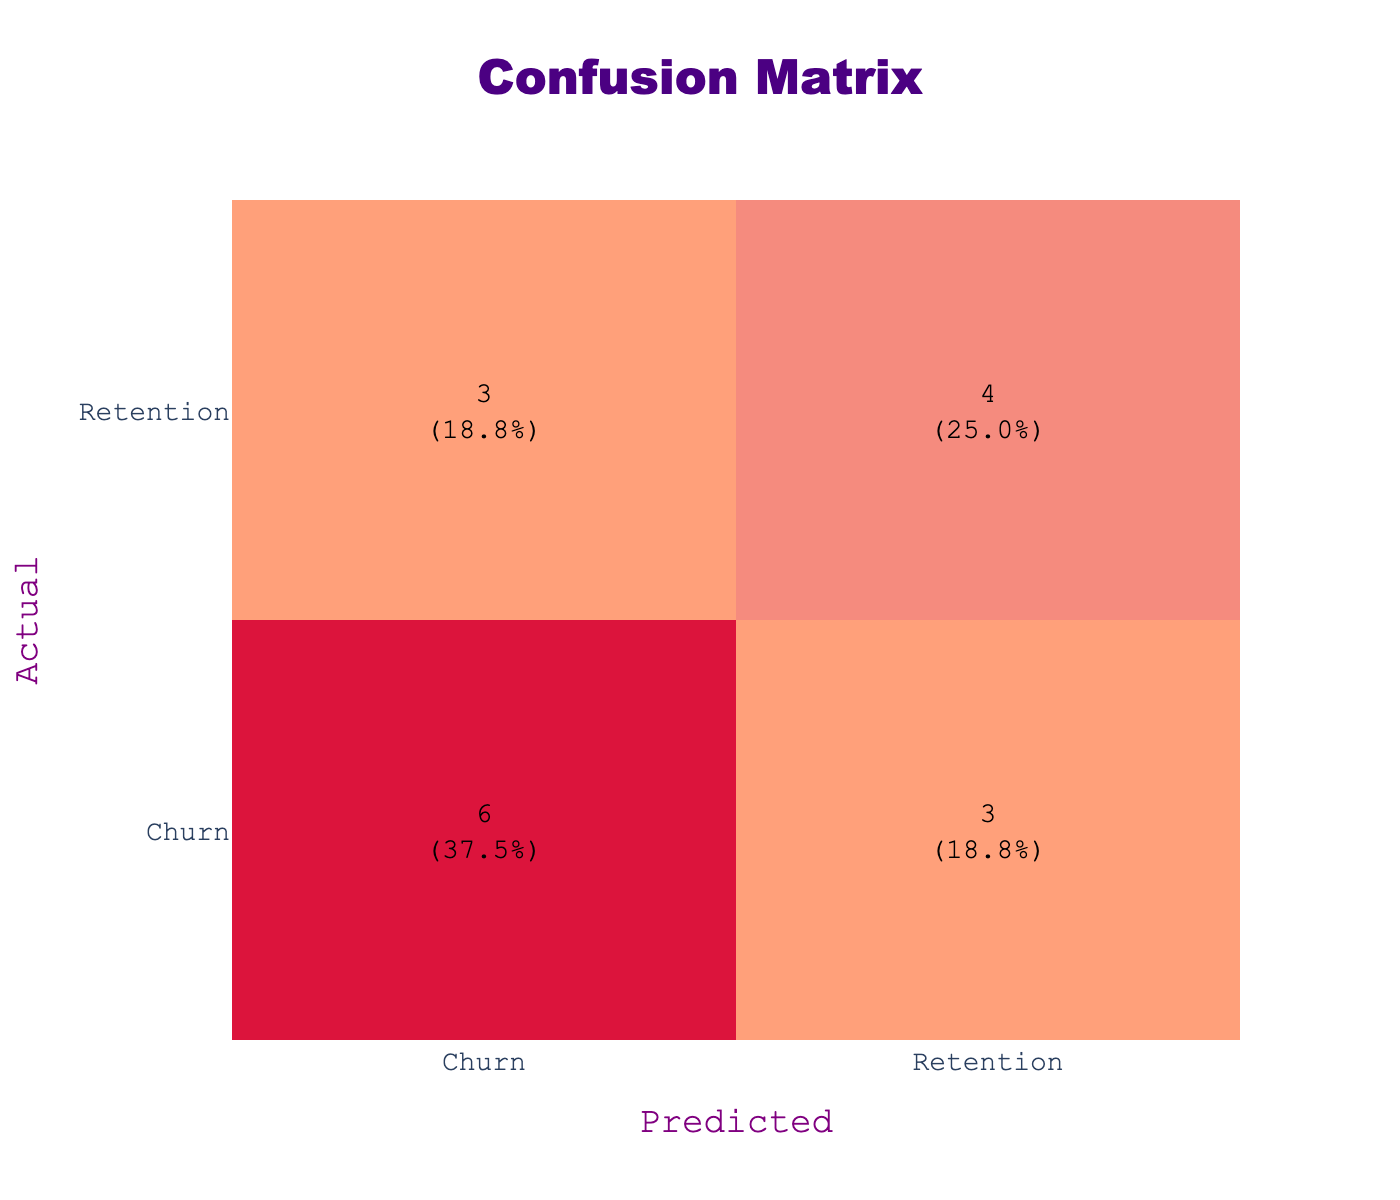What is the total number of customers in the confusion matrix? To find the total number of customers, we sum all the values in the confusion matrix: 4 (True Churn, True Churn) + 2 (True Churn, Retention) + 1 (True Retention, Churn) + 5 (True Retention, Retention) = 12.
Answer: 12 How many customers were correctly predicted to churn? The number of customers correctly predicted to churn corresponds to the cell where actual churn and predicted churn overlap, which has a count of 4.
Answer: 4 What percentage of customers were incorrectly predicted to churn? The incorrectly predicted churn corresponds to the cell where actual retention and predicted churn overlap, which has a count of 1. The total is 12, so the percentage is (1/12) * 100 = 8.3%.
Answer: 8.3% Is the number of correct predictions for retention higher than that for churn? Yes, the number of correctly predicted retainers is 5 (actual retention, predicted retention) versus 4 (actual churn, predicted churn).
Answer: Yes What is the total number of incorrect predictions? Incorrect predictions include customers misclassified in two scenarios: actual churn but predicted retention (3) and actual retention predicted churn (1), resulting in a total of 4 incorrect predictions.
Answer: 4 If a customer is predicted to churn, what is the likelihood that they will actually churn? The probability that a predicted churn is accurate is calculated by taking the number of correctly predicted churns (4) divided by the total number of predicted churns (which is 4 + 1 = 5). Therefore, likelihood = 4 / 5 = 80%.
Answer: 80% How many total predictions were made for retention? To find the total predictions for retention, we add the values in the predicted retention column: 2 (actual churn, predicted retention) + 5 (actual retention, predicted retention) = 7.
Answer: 7 What is the difference between the number of correctly predicted churns and incorrectly predicted churns? The number of correctly predicted churns is 4 while the incorrectly predicted churns is 3. The difference is 4 - 3 = 1.
Answer: 1 What proportion of all customers were actually churners? There are 7 customers who actually churned out of a total of 12 customers. So the proportion of customers who were actual churners is 7 / 12 = 0.5833, or 58.3%.
Answer: 58.3% 